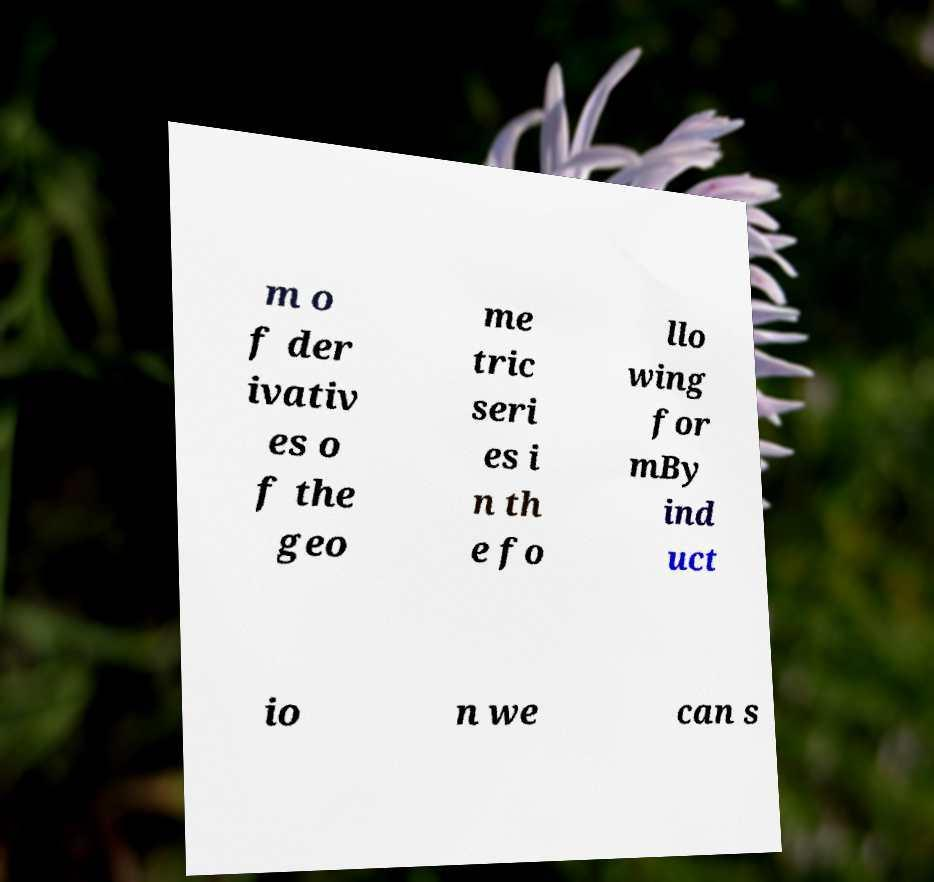Can you read and provide the text displayed in the image?This photo seems to have some interesting text. Can you extract and type it out for me? m o f der ivativ es o f the geo me tric seri es i n th e fo llo wing for mBy ind uct io n we can s 